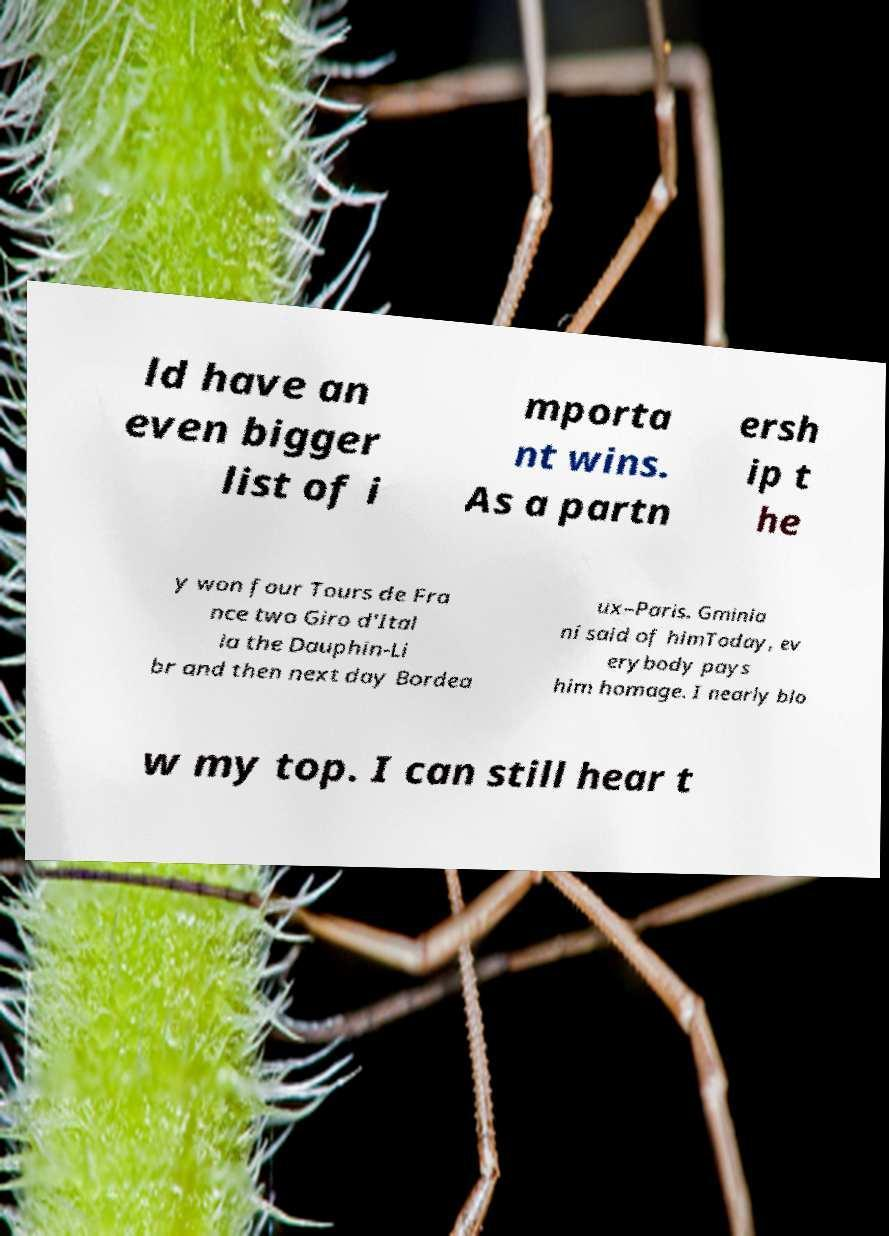What messages or text are displayed in this image? I need them in a readable, typed format. ld have an even bigger list of i mporta nt wins. As a partn ersh ip t he y won four Tours de Fra nce two Giro d'Ital ia the Dauphin-Li br and then next day Bordea ux–Paris. Gminia ni said of himToday, ev erybody pays him homage. I nearly blo w my top. I can still hear t 